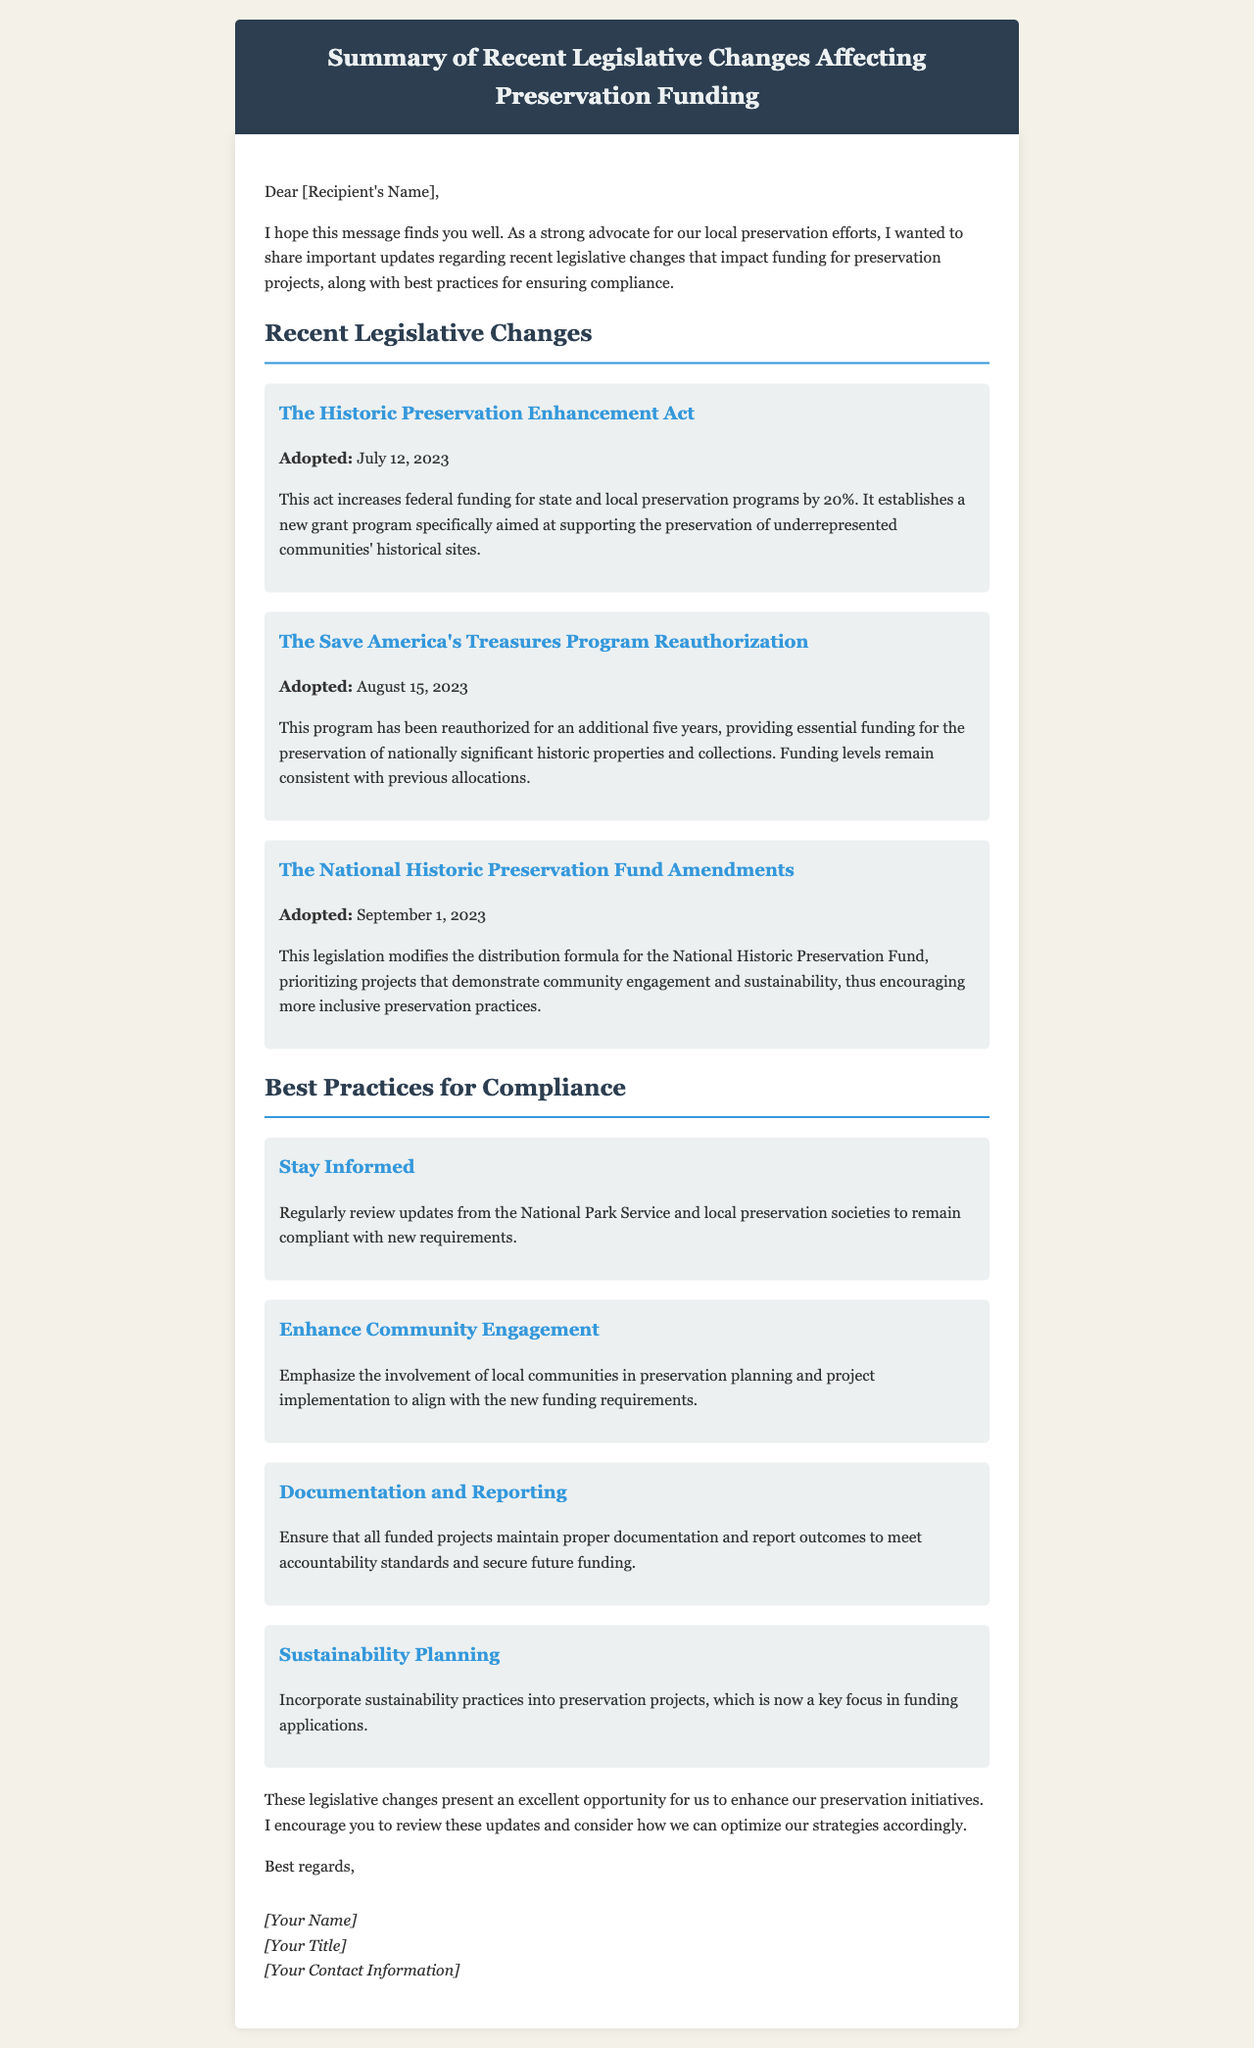What is the name of the act adopted on July 12, 2023? The document mentions "The Historic Preservation Enhancement Act" as the act adopted on this date.
Answer: The Historic Preservation Enhancement Act What percentage increase in funding does the Historic Preservation Enhancement Act provide? The act increases federal funding for state and local preservation programs by 20%.
Answer: 20% When was the Save America's Treasures Program reauthorized? The document states that this program was reauthorized on August 15, 2023.
Answer: August 15, 2023 What key focus area is emphasized in the National Historic Preservation Fund Amendments? The amendments prioritize projects that demonstrate community engagement and sustainability.
Answer: Community engagement and sustainability What is one recommended best practice for compliance mentioned in the email? The document suggests that one of the best practices is to "Stay Informed."
Answer: Stay Informed 